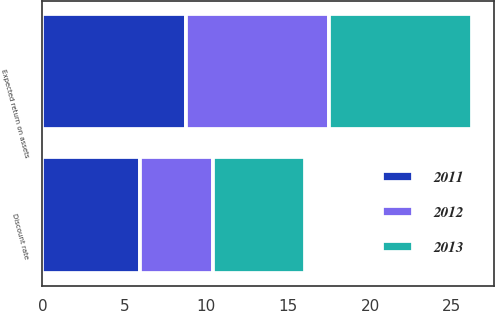Convert chart. <chart><loc_0><loc_0><loc_500><loc_500><stacked_bar_chart><ecel><fcel>Discount rate<fcel>Expected return on assets<nl><fcel>2012<fcel>4.42<fcel>8.75<nl><fcel>2013<fcel>5.64<fcel>8.75<nl><fcel>2011<fcel>5.98<fcel>8.75<nl></chart> 